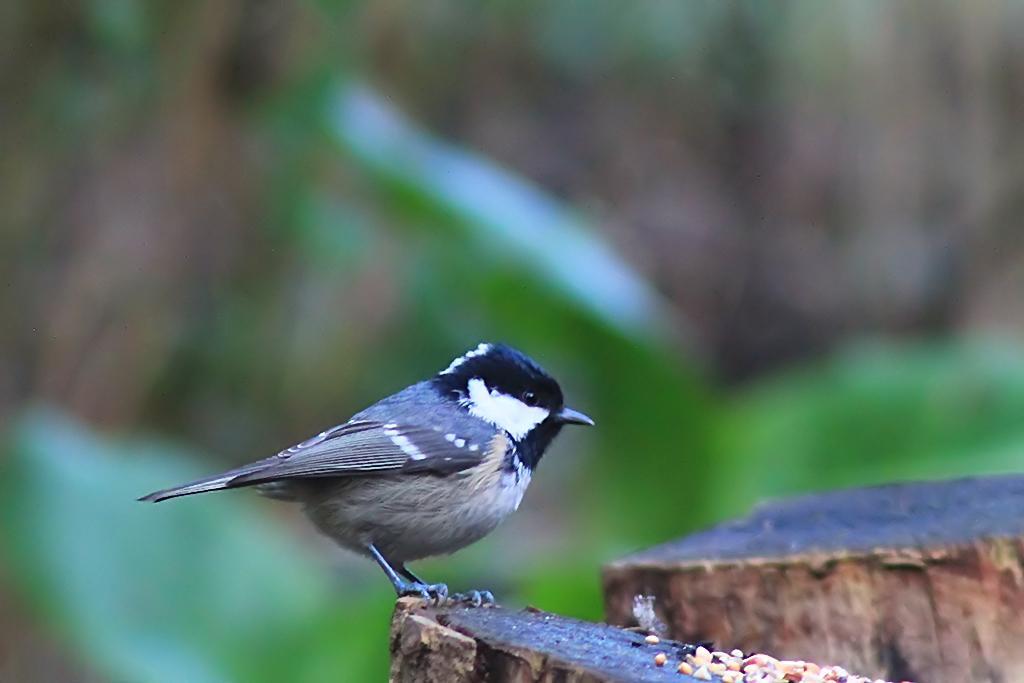Can you describe this image briefly? This image is taken outdoors. In this image the background is a little blurred. In the middle of the image there is a bird on the bark and there are a few grains on the bark. On the right side of the image there is another bark. 